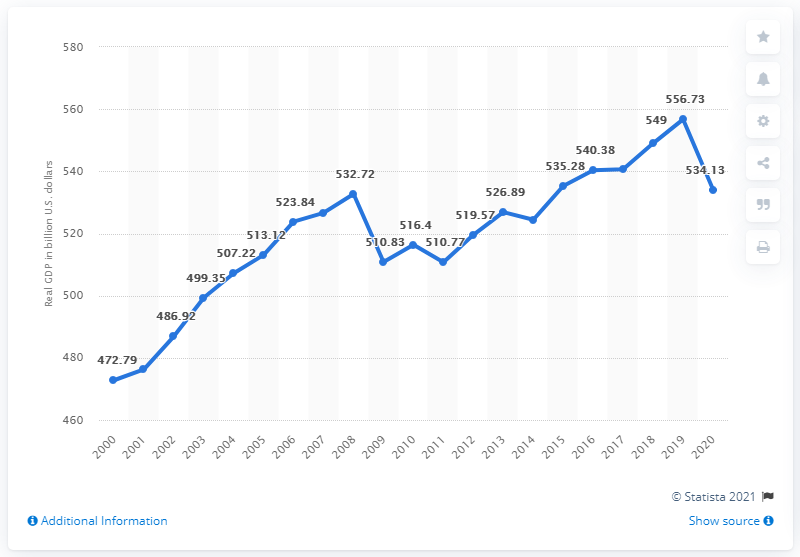Outline some significant characteristics in this image. In the previous year, the Gross Domestic Product (GDP) of New Jersey was 556.73... In 2020, the real GDP of New Jersey was 534.13. 